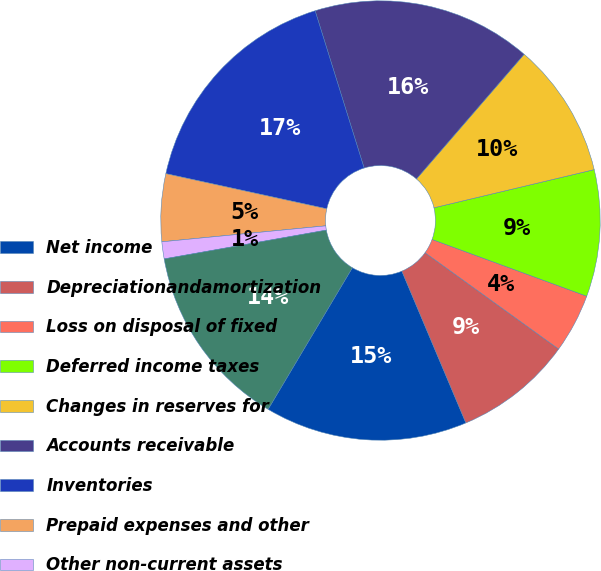Convert chart. <chart><loc_0><loc_0><loc_500><loc_500><pie_chart><fcel>Net income<fcel>Depreciationandamortization<fcel>Loss on disposal of fixed<fcel>Deferred income taxes<fcel>Changes in reserves for<fcel>Accounts receivable<fcel>Inventories<fcel>Prepaid expenses and other<fcel>Other non-current assets<fcel>Accounts payable<nl><fcel>14.9%<fcel>8.7%<fcel>4.35%<fcel>9.32%<fcel>9.94%<fcel>16.15%<fcel>16.77%<fcel>4.97%<fcel>1.25%<fcel>13.66%<nl></chart> 